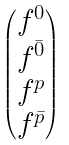Convert formula to latex. <formula><loc_0><loc_0><loc_500><loc_500>\begin{pmatrix} f ^ { 0 } \\ f ^ { \bar { 0 } } \\ f ^ { p } \\ f ^ { \bar { p } } \end{pmatrix}</formula> 